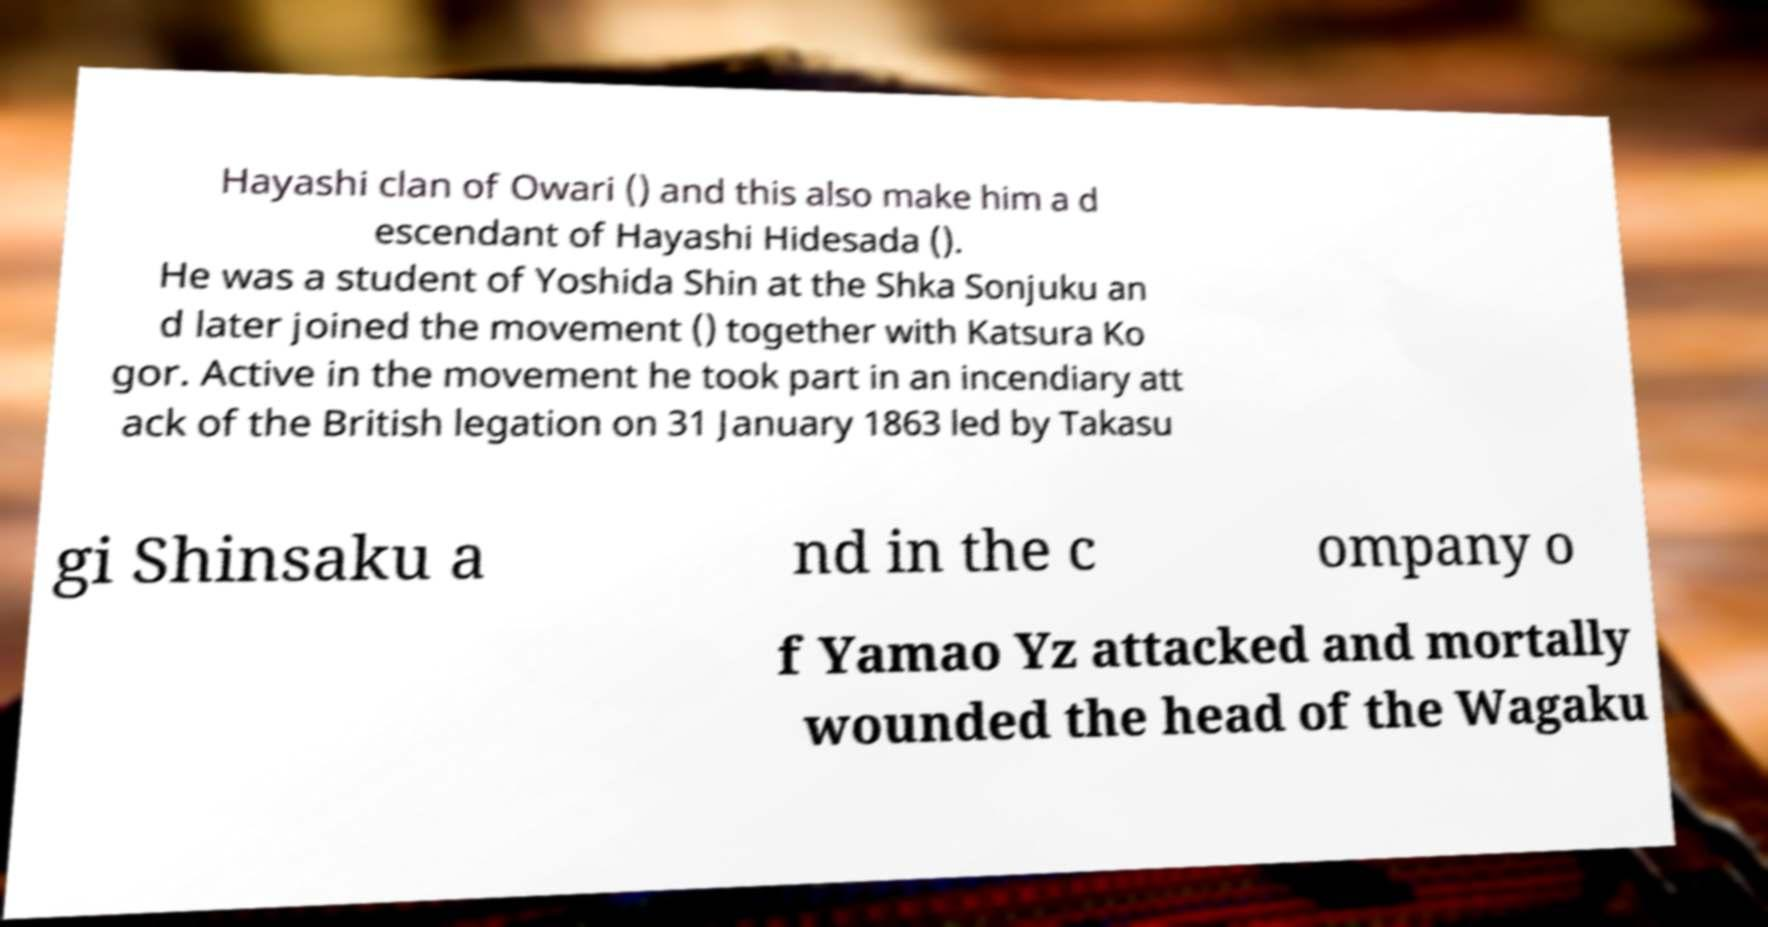For documentation purposes, I need the text within this image transcribed. Could you provide that? Hayashi clan of Owari () and this also make him a d escendant of Hayashi Hidesada (). He was a student of Yoshida Shin at the Shka Sonjuku an d later joined the movement () together with Katsura Ko gor. Active in the movement he took part in an incendiary att ack of the British legation on 31 January 1863 led by Takasu gi Shinsaku a nd in the c ompany o f Yamao Yz attacked and mortally wounded the head of the Wagaku 